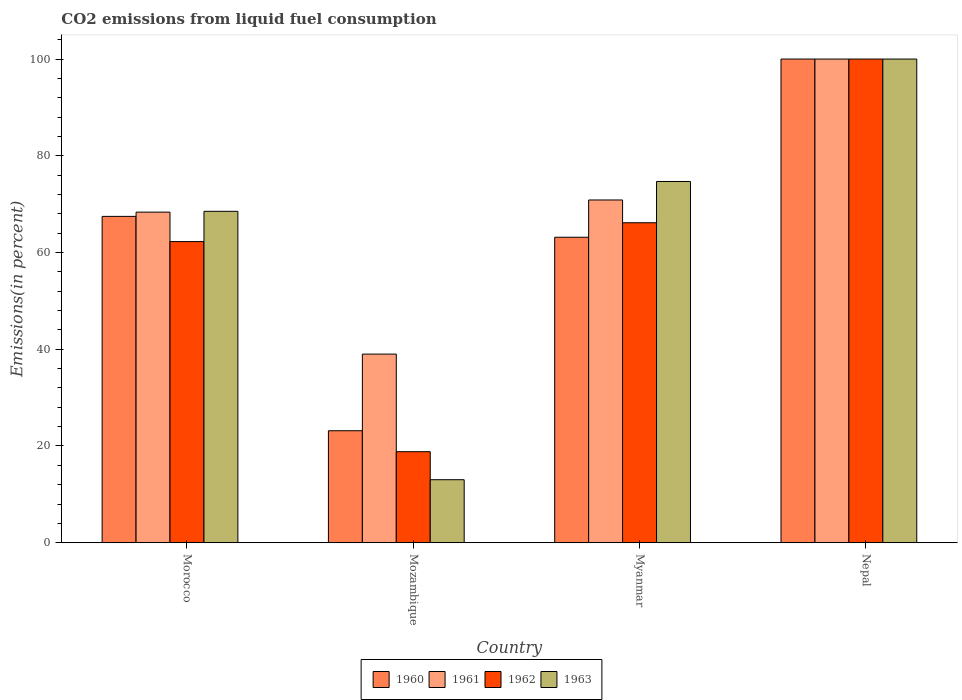Are the number of bars per tick equal to the number of legend labels?
Your response must be concise. Yes. How many bars are there on the 4th tick from the left?
Your answer should be very brief. 4. How many bars are there on the 2nd tick from the right?
Your answer should be very brief. 4. What is the label of the 1st group of bars from the left?
Your answer should be compact. Morocco. What is the total CO2 emitted in 1962 in Mozambique?
Ensure brevity in your answer.  18.82. Across all countries, what is the maximum total CO2 emitted in 1963?
Provide a short and direct response. 100. Across all countries, what is the minimum total CO2 emitted in 1962?
Ensure brevity in your answer.  18.82. In which country was the total CO2 emitted in 1962 maximum?
Provide a succinct answer. Nepal. In which country was the total CO2 emitted in 1960 minimum?
Your answer should be compact. Mozambique. What is the total total CO2 emitted in 1960 in the graph?
Ensure brevity in your answer.  253.78. What is the difference between the total CO2 emitted in 1963 in Mozambique and that in Myanmar?
Keep it short and to the point. -61.66. What is the difference between the total CO2 emitted in 1961 in Mozambique and the total CO2 emitted in 1963 in Morocco?
Make the answer very short. -29.52. What is the average total CO2 emitted in 1960 per country?
Your answer should be very brief. 63.45. What is the difference between the total CO2 emitted of/in 1960 and total CO2 emitted of/in 1963 in Morocco?
Your answer should be very brief. -1.05. What is the ratio of the total CO2 emitted in 1962 in Morocco to that in Myanmar?
Provide a succinct answer. 0.94. Is the difference between the total CO2 emitted in 1960 in Myanmar and Nepal greater than the difference between the total CO2 emitted in 1963 in Myanmar and Nepal?
Offer a very short reply. No. What is the difference between the highest and the second highest total CO2 emitted in 1960?
Ensure brevity in your answer.  -32.53. What is the difference between the highest and the lowest total CO2 emitted in 1961?
Offer a terse response. 61. In how many countries, is the total CO2 emitted in 1960 greater than the average total CO2 emitted in 1960 taken over all countries?
Offer a terse response. 2. Is the sum of the total CO2 emitted in 1962 in Morocco and Myanmar greater than the maximum total CO2 emitted in 1960 across all countries?
Your response must be concise. Yes. What does the 2nd bar from the left in Myanmar represents?
Your answer should be very brief. 1961. What does the 2nd bar from the right in Nepal represents?
Your response must be concise. 1962. How many bars are there?
Your answer should be very brief. 16. Are all the bars in the graph horizontal?
Provide a short and direct response. No. What is the difference between two consecutive major ticks on the Y-axis?
Make the answer very short. 20. Are the values on the major ticks of Y-axis written in scientific E-notation?
Offer a very short reply. No. Where does the legend appear in the graph?
Offer a very short reply. Bottom center. How many legend labels are there?
Your response must be concise. 4. How are the legend labels stacked?
Offer a very short reply. Horizontal. What is the title of the graph?
Make the answer very short. CO2 emissions from liquid fuel consumption. Does "1985" appear as one of the legend labels in the graph?
Offer a terse response. No. What is the label or title of the Y-axis?
Offer a terse response. Emissions(in percent). What is the Emissions(in percent) in 1960 in Morocco?
Provide a short and direct response. 67.47. What is the Emissions(in percent) in 1961 in Morocco?
Provide a succinct answer. 68.35. What is the Emissions(in percent) of 1962 in Morocco?
Offer a very short reply. 62.26. What is the Emissions(in percent) of 1963 in Morocco?
Offer a very short reply. 68.52. What is the Emissions(in percent) of 1960 in Mozambique?
Offer a very short reply. 23.15. What is the Emissions(in percent) in 1961 in Mozambique?
Offer a terse response. 39. What is the Emissions(in percent) in 1962 in Mozambique?
Offer a very short reply. 18.82. What is the Emissions(in percent) in 1963 in Mozambique?
Your answer should be compact. 13.02. What is the Emissions(in percent) of 1960 in Myanmar?
Provide a succinct answer. 63.16. What is the Emissions(in percent) in 1961 in Myanmar?
Ensure brevity in your answer.  70.86. What is the Emissions(in percent) of 1962 in Myanmar?
Provide a short and direct response. 66.16. What is the Emissions(in percent) of 1963 in Myanmar?
Offer a very short reply. 74.69. What is the Emissions(in percent) in 1960 in Nepal?
Provide a succinct answer. 100. What is the Emissions(in percent) in 1961 in Nepal?
Provide a short and direct response. 100. Across all countries, what is the maximum Emissions(in percent) in 1960?
Your answer should be very brief. 100. Across all countries, what is the maximum Emissions(in percent) of 1961?
Offer a very short reply. 100. Across all countries, what is the maximum Emissions(in percent) in 1962?
Provide a succinct answer. 100. Across all countries, what is the minimum Emissions(in percent) in 1960?
Give a very brief answer. 23.15. Across all countries, what is the minimum Emissions(in percent) in 1961?
Provide a short and direct response. 39. Across all countries, what is the minimum Emissions(in percent) in 1962?
Provide a short and direct response. 18.82. Across all countries, what is the minimum Emissions(in percent) in 1963?
Your response must be concise. 13.02. What is the total Emissions(in percent) in 1960 in the graph?
Make the answer very short. 253.78. What is the total Emissions(in percent) in 1961 in the graph?
Offer a terse response. 278.21. What is the total Emissions(in percent) in 1962 in the graph?
Provide a short and direct response. 247.24. What is the total Emissions(in percent) of 1963 in the graph?
Offer a very short reply. 256.23. What is the difference between the Emissions(in percent) of 1960 in Morocco and that in Mozambique?
Make the answer very short. 44.32. What is the difference between the Emissions(in percent) of 1961 in Morocco and that in Mozambique?
Ensure brevity in your answer.  29.35. What is the difference between the Emissions(in percent) in 1962 in Morocco and that in Mozambique?
Offer a terse response. 43.44. What is the difference between the Emissions(in percent) of 1963 in Morocco and that in Mozambique?
Provide a short and direct response. 55.49. What is the difference between the Emissions(in percent) of 1960 in Morocco and that in Myanmar?
Your response must be concise. 4.31. What is the difference between the Emissions(in percent) of 1961 in Morocco and that in Myanmar?
Your response must be concise. -2.51. What is the difference between the Emissions(in percent) of 1962 in Morocco and that in Myanmar?
Your answer should be compact. -3.9. What is the difference between the Emissions(in percent) in 1963 in Morocco and that in Myanmar?
Ensure brevity in your answer.  -6.17. What is the difference between the Emissions(in percent) in 1960 in Morocco and that in Nepal?
Give a very brief answer. -32.53. What is the difference between the Emissions(in percent) in 1961 in Morocco and that in Nepal?
Make the answer very short. -31.65. What is the difference between the Emissions(in percent) of 1962 in Morocco and that in Nepal?
Give a very brief answer. -37.74. What is the difference between the Emissions(in percent) of 1963 in Morocco and that in Nepal?
Your answer should be compact. -31.48. What is the difference between the Emissions(in percent) of 1960 in Mozambique and that in Myanmar?
Ensure brevity in your answer.  -40.01. What is the difference between the Emissions(in percent) in 1961 in Mozambique and that in Myanmar?
Your answer should be very brief. -31.87. What is the difference between the Emissions(in percent) in 1962 in Mozambique and that in Myanmar?
Your answer should be very brief. -47.34. What is the difference between the Emissions(in percent) of 1963 in Mozambique and that in Myanmar?
Make the answer very short. -61.66. What is the difference between the Emissions(in percent) of 1960 in Mozambique and that in Nepal?
Make the answer very short. -76.85. What is the difference between the Emissions(in percent) of 1961 in Mozambique and that in Nepal?
Provide a succinct answer. -61. What is the difference between the Emissions(in percent) in 1962 in Mozambique and that in Nepal?
Provide a short and direct response. -81.18. What is the difference between the Emissions(in percent) of 1963 in Mozambique and that in Nepal?
Provide a short and direct response. -86.98. What is the difference between the Emissions(in percent) in 1960 in Myanmar and that in Nepal?
Your answer should be compact. -36.84. What is the difference between the Emissions(in percent) in 1961 in Myanmar and that in Nepal?
Offer a very short reply. -29.14. What is the difference between the Emissions(in percent) in 1962 in Myanmar and that in Nepal?
Give a very brief answer. -33.84. What is the difference between the Emissions(in percent) in 1963 in Myanmar and that in Nepal?
Your answer should be very brief. -25.31. What is the difference between the Emissions(in percent) of 1960 in Morocco and the Emissions(in percent) of 1961 in Mozambique?
Keep it short and to the point. 28.48. What is the difference between the Emissions(in percent) in 1960 in Morocco and the Emissions(in percent) in 1962 in Mozambique?
Your answer should be very brief. 48.65. What is the difference between the Emissions(in percent) of 1960 in Morocco and the Emissions(in percent) of 1963 in Mozambique?
Keep it short and to the point. 54.45. What is the difference between the Emissions(in percent) of 1961 in Morocco and the Emissions(in percent) of 1962 in Mozambique?
Ensure brevity in your answer.  49.53. What is the difference between the Emissions(in percent) of 1961 in Morocco and the Emissions(in percent) of 1963 in Mozambique?
Your answer should be compact. 55.33. What is the difference between the Emissions(in percent) of 1962 in Morocco and the Emissions(in percent) of 1963 in Mozambique?
Offer a terse response. 49.24. What is the difference between the Emissions(in percent) of 1960 in Morocco and the Emissions(in percent) of 1961 in Myanmar?
Provide a succinct answer. -3.39. What is the difference between the Emissions(in percent) of 1960 in Morocco and the Emissions(in percent) of 1962 in Myanmar?
Offer a terse response. 1.31. What is the difference between the Emissions(in percent) of 1960 in Morocco and the Emissions(in percent) of 1963 in Myanmar?
Provide a short and direct response. -7.21. What is the difference between the Emissions(in percent) of 1961 in Morocco and the Emissions(in percent) of 1962 in Myanmar?
Your answer should be compact. 2.19. What is the difference between the Emissions(in percent) of 1961 in Morocco and the Emissions(in percent) of 1963 in Myanmar?
Your answer should be very brief. -6.34. What is the difference between the Emissions(in percent) in 1962 in Morocco and the Emissions(in percent) in 1963 in Myanmar?
Make the answer very short. -12.43. What is the difference between the Emissions(in percent) in 1960 in Morocco and the Emissions(in percent) in 1961 in Nepal?
Your answer should be very brief. -32.53. What is the difference between the Emissions(in percent) in 1960 in Morocco and the Emissions(in percent) in 1962 in Nepal?
Your answer should be very brief. -32.53. What is the difference between the Emissions(in percent) of 1960 in Morocco and the Emissions(in percent) of 1963 in Nepal?
Your response must be concise. -32.53. What is the difference between the Emissions(in percent) in 1961 in Morocco and the Emissions(in percent) in 1962 in Nepal?
Provide a succinct answer. -31.65. What is the difference between the Emissions(in percent) in 1961 in Morocco and the Emissions(in percent) in 1963 in Nepal?
Provide a succinct answer. -31.65. What is the difference between the Emissions(in percent) in 1962 in Morocco and the Emissions(in percent) in 1963 in Nepal?
Make the answer very short. -37.74. What is the difference between the Emissions(in percent) in 1960 in Mozambique and the Emissions(in percent) in 1961 in Myanmar?
Offer a terse response. -47.71. What is the difference between the Emissions(in percent) in 1960 in Mozambique and the Emissions(in percent) in 1962 in Myanmar?
Ensure brevity in your answer.  -43.01. What is the difference between the Emissions(in percent) of 1960 in Mozambique and the Emissions(in percent) of 1963 in Myanmar?
Your answer should be compact. -51.54. What is the difference between the Emissions(in percent) of 1961 in Mozambique and the Emissions(in percent) of 1962 in Myanmar?
Your response must be concise. -27.16. What is the difference between the Emissions(in percent) of 1961 in Mozambique and the Emissions(in percent) of 1963 in Myanmar?
Your answer should be compact. -35.69. What is the difference between the Emissions(in percent) in 1962 in Mozambique and the Emissions(in percent) in 1963 in Myanmar?
Provide a succinct answer. -55.87. What is the difference between the Emissions(in percent) of 1960 in Mozambique and the Emissions(in percent) of 1961 in Nepal?
Your answer should be very brief. -76.85. What is the difference between the Emissions(in percent) of 1960 in Mozambique and the Emissions(in percent) of 1962 in Nepal?
Your answer should be compact. -76.85. What is the difference between the Emissions(in percent) of 1960 in Mozambique and the Emissions(in percent) of 1963 in Nepal?
Keep it short and to the point. -76.85. What is the difference between the Emissions(in percent) of 1961 in Mozambique and the Emissions(in percent) of 1962 in Nepal?
Keep it short and to the point. -61. What is the difference between the Emissions(in percent) of 1961 in Mozambique and the Emissions(in percent) of 1963 in Nepal?
Ensure brevity in your answer.  -61. What is the difference between the Emissions(in percent) of 1962 in Mozambique and the Emissions(in percent) of 1963 in Nepal?
Ensure brevity in your answer.  -81.18. What is the difference between the Emissions(in percent) in 1960 in Myanmar and the Emissions(in percent) in 1961 in Nepal?
Your answer should be compact. -36.84. What is the difference between the Emissions(in percent) in 1960 in Myanmar and the Emissions(in percent) in 1962 in Nepal?
Your answer should be compact. -36.84. What is the difference between the Emissions(in percent) of 1960 in Myanmar and the Emissions(in percent) of 1963 in Nepal?
Give a very brief answer. -36.84. What is the difference between the Emissions(in percent) of 1961 in Myanmar and the Emissions(in percent) of 1962 in Nepal?
Provide a succinct answer. -29.14. What is the difference between the Emissions(in percent) in 1961 in Myanmar and the Emissions(in percent) in 1963 in Nepal?
Your answer should be compact. -29.14. What is the difference between the Emissions(in percent) in 1962 in Myanmar and the Emissions(in percent) in 1963 in Nepal?
Make the answer very short. -33.84. What is the average Emissions(in percent) in 1960 per country?
Give a very brief answer. 63.45. What is the average Emissions(in percent) of 1961 per country?
Your answer should be compact. 69.55. What is the average Emissions(in percent) in 1962 per country?
Your answer should be compact. 61.81. What is the average Emissions(in percent) in 1963 per country?
Your response must be concise. 64.06. What is the difference between the Emissions(in percent) in 1960 and Emissions(in percent) in 1961 in Morocco?
Offer a terse response. -0.88. What is the difference between the Emissions(in percent) of 1960 and Emissions(in percent) of 1962 in Morocco?
Offer a terse response. 5.21. What is the difference between the Emissions(in percent) in 1960 and Emissions(in percent) in 1963 in Morocco?
Provide a succinct answer. -1.05. What is the difference between the Emissions(in percent) of 1961 and Emissions(in percent) of 1962 in Morocco?
Offer a very short reply. 6.09. What is the difference between the Emissions(in percent) of 1961 and Emissions(in percent) of 1963 in Morocco?
Offer a terse response. -0.17. What is the difference between the Emissions(in percent) in 1962 and Emissions(in percent) in 1963 in Morocco?
Make the answer very short. -6.26. What is the difference between the Emissions(in percent) in 1960 and Emissions(in percent) in 1961 in Mozambique?
Make the answer very short. -15.85. What is the difference between the Emissions(in percent) of 1960 and Emissions(in percent) of 1962 in Mozambique?
Your response must be concise. 4.33. What is the difference between the Emissions(in percent) of 1960 and Emissions(in percent) of 1963 in Mozambique?
Your answer should be compact. 10.13. What is the difference between the Emissions(in percent) of 1961 and Emissions(in percent) of 1962 in Mozambique?
Make the answer very short. 20.18. What is the difference between the Emissions(in percent) in 1961 and Emissions(in percent) in 1963 in Mozambique?
Your response must be concise. 25.97. What is the difference between the Emissions(in percent) of 1962 and Emissions(in percent) of 1963 in Mozambique?
Provide a succinct answer. 5.79. What is the difference between the Emissions(in percent) of 1960 and Emissions(in percent) of 1961 in Myanmar?
Keep it short and to the point. -7.7. What is the difference between the Emissions(in percent) of 1960 and Emissions(in percent) of 1962 in Myanmar?
Offer a terse response. -3. What is the difference between the Emissions(in percent) in 1960 and Emissions(in percent) in 1963 in Myanmar?
Provide a succinct answer. -11.53. What is the difference between the Emissions(in percent) in 1961 and Emissions(in percent) in 1962 in Myanmar?
Give a very brief answer. 4.71. What is the difference between the Emissions(in percent) in 1961 and Emissions(in percent) in 1963 in Myanmar?
Provide a succinct answer. -3.82. What is the difference between the Emissions(in percent) of 1962 and Emissions(in percent) of 1963 in Myanmar?
Offer a very short reply. -8.53. What is the difference between the Emissions(in percent) of 1960 and Emissions(in percent) of 1961 in Nepal?
Keep it short and to the point. 0. What is the difference between the Emissions(in percent) in 1961 and Emissions(in percent) in 1963 in Nepal?
Offer a very short reply. 0. What is the difference between the Emissions(in percent) of 1962 and Emissions(in percent) of 1963 in Nepal?
Ensure brevity in your answer.  0. What is the ratio of the Emissions(in percent) of 1960 in Morocco to that in Mozambique?
Ensure brevity in your answer.  2.91. What is the ratio of the Emissions(in percent) of 1961 in Morocco to that in Mozambique?
Offer a terse response. 1.75. What is the ratio of the Emissions(in percent) in 1962 in Morocco to that in Mozambique?
Keep it short and to the point. 3.31. What is the ratio of the Emissions(in percent) of 1963 in Morocco to that in Mozambique?
Offer a terse response. 5.26. What is the ratio of the Emissions(in percent) in 1960 in Morocco to that in Myanmar?
Your response must be concise. 1.07. What is the ratio of the Emissions(in percent) of 1961 in Morocco to that in Myanmar?
Your answer should be compact. 0.96. What is the ratio of the Emissions(in percent) in 1962 in Morocco to that in Myanmar?
Make the answer very short. 0.94. What is the ratio of the Emissions(in percent) in 1963 in Morocco to that in Myanmar?
Provide a succinct answer. 0.92. What is the ratio of the Emissions(in percent) of 1960 in Morocco to that in Nepal?
Provide a short and direct response. 0.67. What is the ratio of the Emissions(in percent) in 1961 in Morocco to that in Nepal?
Your response must be concise. 0.68. What is the ratio of the Emissions(in percent) in 1962 in Morocco to that in Nepal?
Offer a very short reply. 0.62. What is the ratio of the Emissions(in percent) in 1963 in Morocco to that in Nepal?
Keep it short and to the point. 0.69. What is the ratio of the Emissions(in percent) in 1960 in Mozambique to that in Myanmar?
Offer a very short reply. 0.37. What is the ratio of the Emissions(in percent) in 1961 in Mozambique to that in Myanmar?
Offer a terse response. 0.55. What is the ratio of the Emissions(in percent) of 1962 in Mozambique to that in Myanmar?
Give a very brief answer. 0.28. What is the ratio of the Emissions(in percent) of 1963 in Mozambique to that in Myanmar?
Ensure brevity in your answer.  0.17. What is the ratio of the Emissions(in percent) in 1960 in Mozambique to that in Nepal?
Your answer should be very brief. 0.23. What is the ratio of the Emissions(in percent) of 1961 in Mozambique to that in Nepal?
Provide a short and direct response. 0.39. What is the ratio of the Emissions(in percent) in 1962 in Mozambique to that in Nepal?
Provide a succinct answer. 0.19. What is the ratio of the Emissions(in percent) of 1963 in Mozambique to that in Nepal?
Keep it short and to the point. 0.13. What is the ratio of the Emissions(in percent) in 1960 in Myanmar to that in Nepal?
Your response must be concise. 0.63. What is the ratio of the Emissions(in percent) in 1961 in Myanmar to that in Nepal?
Your response must be concise. 0.71. What is the ratio of the Emissions(in percent) in 1962 in Myanmar to that in Nepal?
Make the answer very short. 0.66. What is the ratio of the Emissions(in percent) of 1963 in Myanmar to that in Nepal?
Your answer should be very brief. 0.75. What is the difference between the highest and the second highest Emissions(in percent) in 1960?
Your answer should be compact. 32.53. What is the difference between the highest and the second highest Emissions(in percent) of 1961?
Make the answer very short. 29.14. What is the difference between the highest and the second highest Emissions(in percent) in 1962?
Give a very brief answer. 33.84. What is the difference between the highest and the second highest Emissions(in percent) in 1963?
Provide a short and direct response. 25.31. What is the difference between the highest and the lowest Emissions(in percent) of 1960?
Keep it short and to the point. 76.85. What is the difference between the highest and the lowest Emissions(in percent) in 1961?
Offer a terse response. 61. What is the difference between the highest and the lowest Emissions(in percent) in 1962?
Make the answer very short. 81.18. What is the difference between the highest and the lowest Emissions(in percent) of 1963?
Offer a terse response. 86.98. 